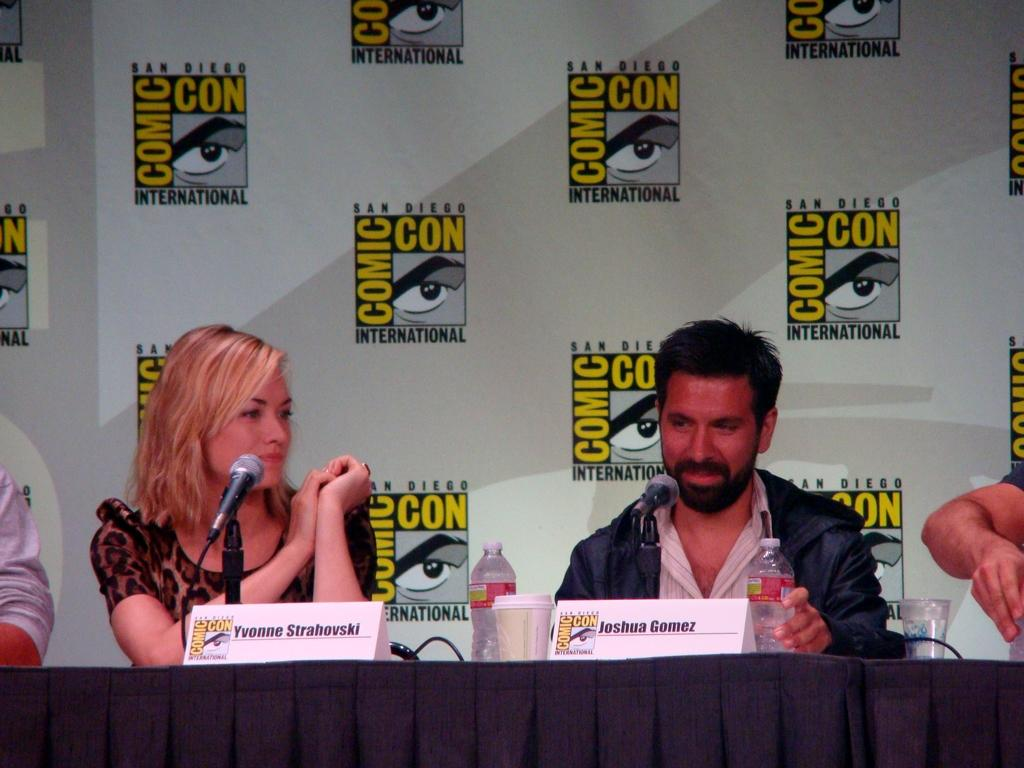How many people are in the image? There are people in the image, but the exact number is not specified in the facts. What is in front of the people? There is a table in front of the people. What items can be seen on the table? There are bottles, a cup, a glass of water, name boards, and mics on the table. What is visible in the background of the image? There is a hoarding in the background. What is the man holding in the image? The man is holding a bottle. What type of locket is the squirrel wearing in the image? There is no squirrel or locket present in the image. What country is the hoarding promoting in the image? The facts do not mention any specific country or promotion related to the hoarding in the image. 